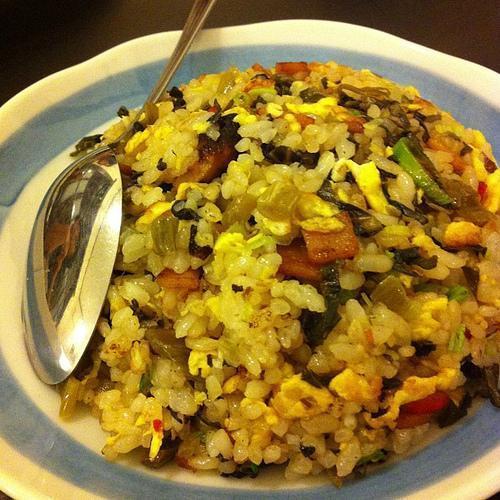How many spoons are there?
Give a very brief answer. 1. 